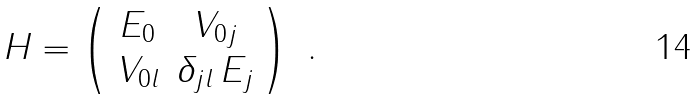Convert formula to latex. <formula><loc_0><loc_0><loc_500><loc_500>H = \left ( \begin{array} { c c } E _ { 0 } & V _ { 0 j } \\ V _ { 0 l } & \delta _ { j l } \, E _ { j } \end{array} \right ) \ .</formula> 